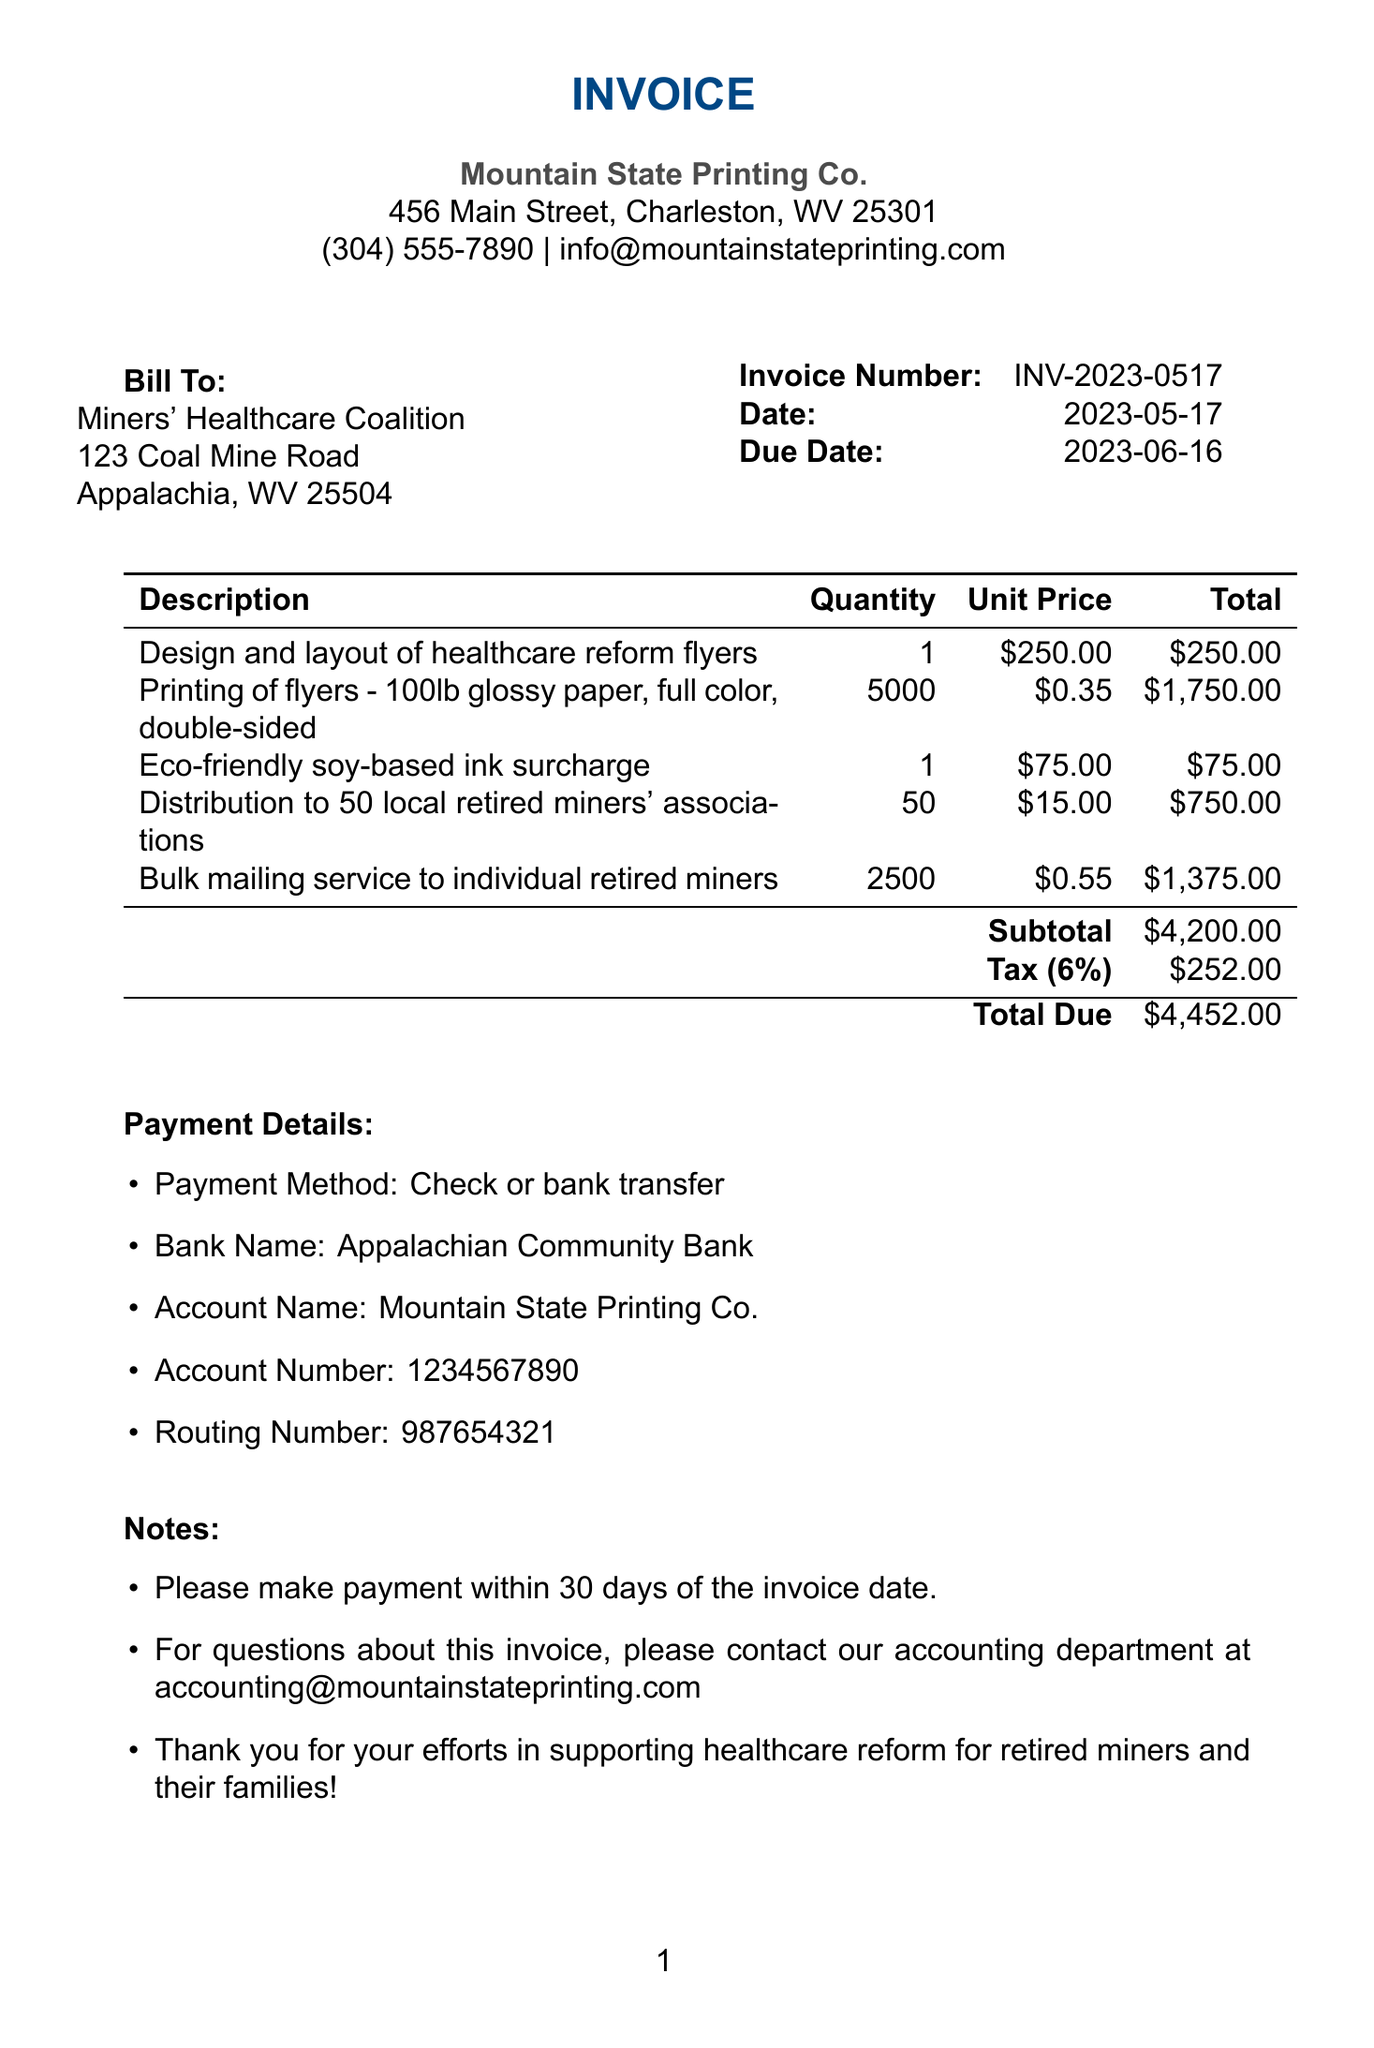What is the invoice number? The invoice number is explicitly stated in the document under the invoice details section.
Answer: INV-2023-0517 What is the due date for payment? The due date is specified in the invoice details and indicates when payment is required.
Answer: 2023-06-16 How many flyers were printed? The quantity of printed flyers is detailed in the items section of the invoice.
Answer: 5000 What is the total amount due? The total amount due is located in the totals section, which sums all costs including taxes.
Answer: $4452.00 What surcharge is included in the invoice? The invoice lists an eco-friendly soy-based ink surcharge indicating an additional cost.
Answer: Eco-friendly soy-based ink surcharge What is the payment method mentioned? The payment method is noted in the payment details section of the invoice.
Answer: Check or bank transfer How many local associations will receive distribution? The distribution quantity is mentioned regarding the local retired miners' associations.
Answer: 50 What is the subtotal before tax? The subtotal is clearly indicated in the totals section before the tax is applied.
Answer: $4200.00 What type of paper was used for printing? The invoice states the type of paper used for printing flyers, highlighting its quality.
Answer: 100lb glossy paper 